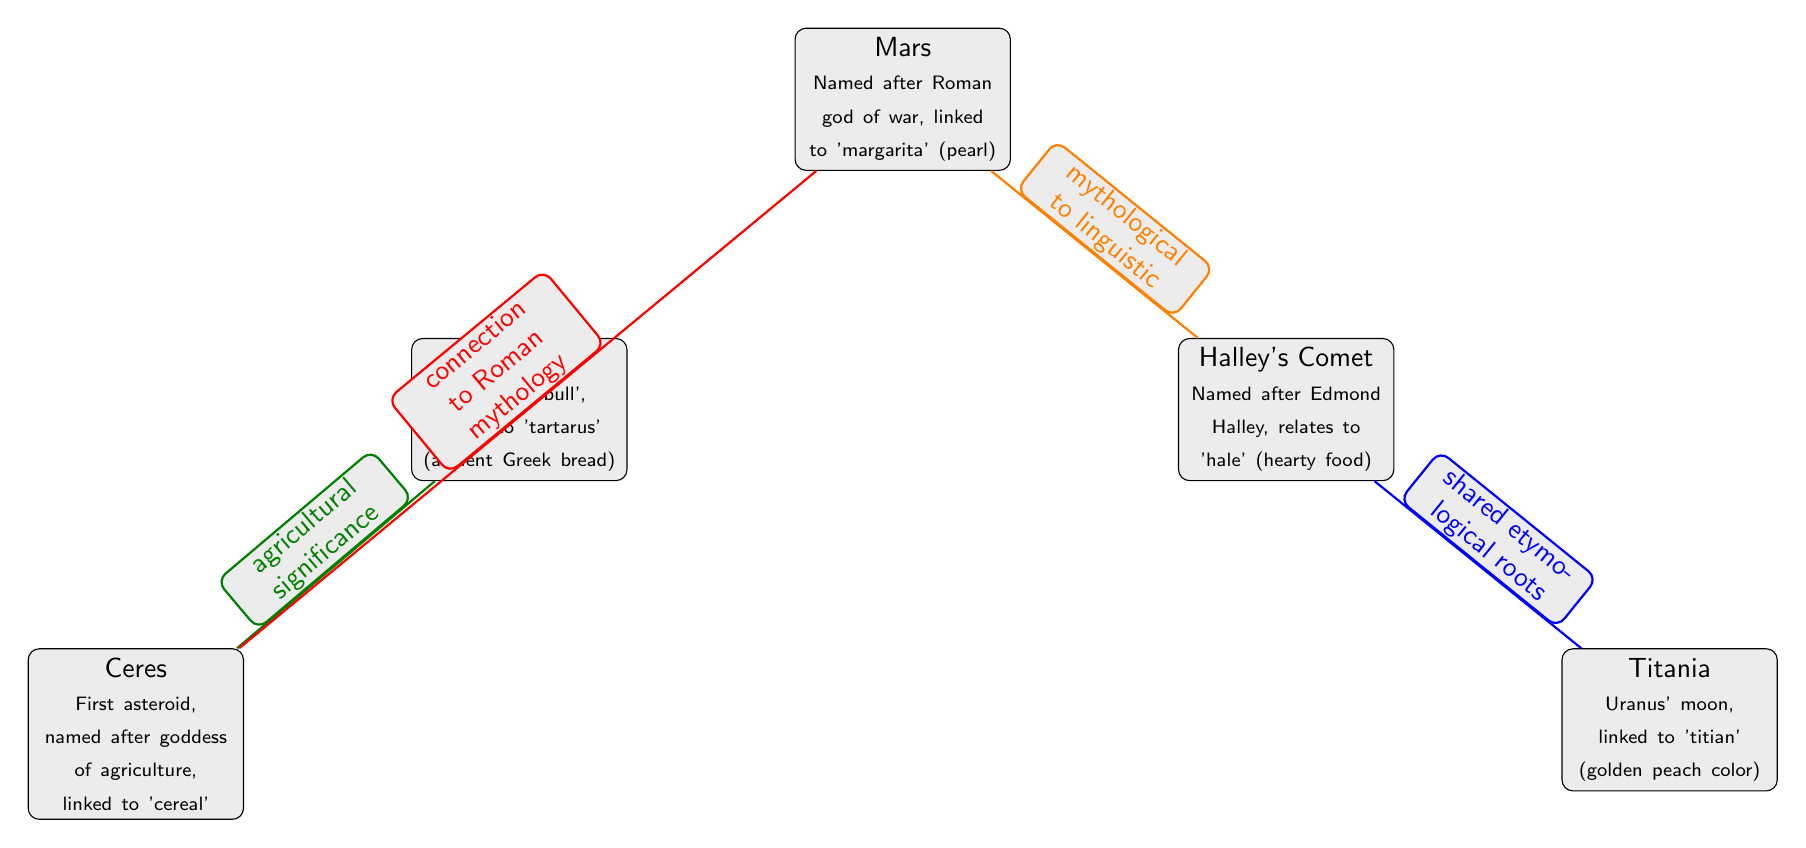What is the relationship type between Mars and Halley's Comet? The diagram labels the relationship between Mars and Halley's Comet as "mythological to linguistic," indicating how the two terms are connected through mythology and language.
Answer: mythological to linguistic How many nodes are present in the diagram? Counting the distinct nodes, we find that there are a total of five nodes: Mars, Taurus, Halley's Comet, Titania, and Ceres.
Answer: 5 What term is linked to the goddess of agriculture? The diagram states that Ceres is named after the goddess of agriculture, linking her to the term ‘cereal’.
Answer: cereal Which node represents a connection to Roman mythology and what is the other node? The relationship labeled "connection to Roman mythology" connects Mars to Ceres, indicating that Mars represents aspects of Roman mythology while Ceres is also linked to the agricultural implications.
Answer: Mars and Ceres What color is the edge connecting Taurus and Ceres? The edge from Taurus to Ceres is colored green!50!black, which emphasizes their connection through agricultural significance.
Answer: green!50!black Which two nodes share etymological roots? The diagram specifies a relationship indicating shared etymological roots between Halley's Comet and Titania, showing their linguistic connection.
Answer: Halley's Comet and Titania What is the significance of the term 'tartarus' in relation to Taurus? The diagram indicates that Taurus is linked to 'tartarus,' described as ancient Greek bread, showing that the term has a cultural significance tied to food.
Answer: ancient Greek bread How is Titania described in the diagram? Titania is depicted as Uranus' moon and is linked to the term 'titian,' which refers to a golden peach color, suggesting its aesthetic qualities.
Answer: Uranus' moon What is the etymological link of Halley's Comet? Halley's Comet is etymologically linked to the term 'hale,' which is associated with hearty food, suggesting a cultural connection between the two concepts.
Answer: hearty food 